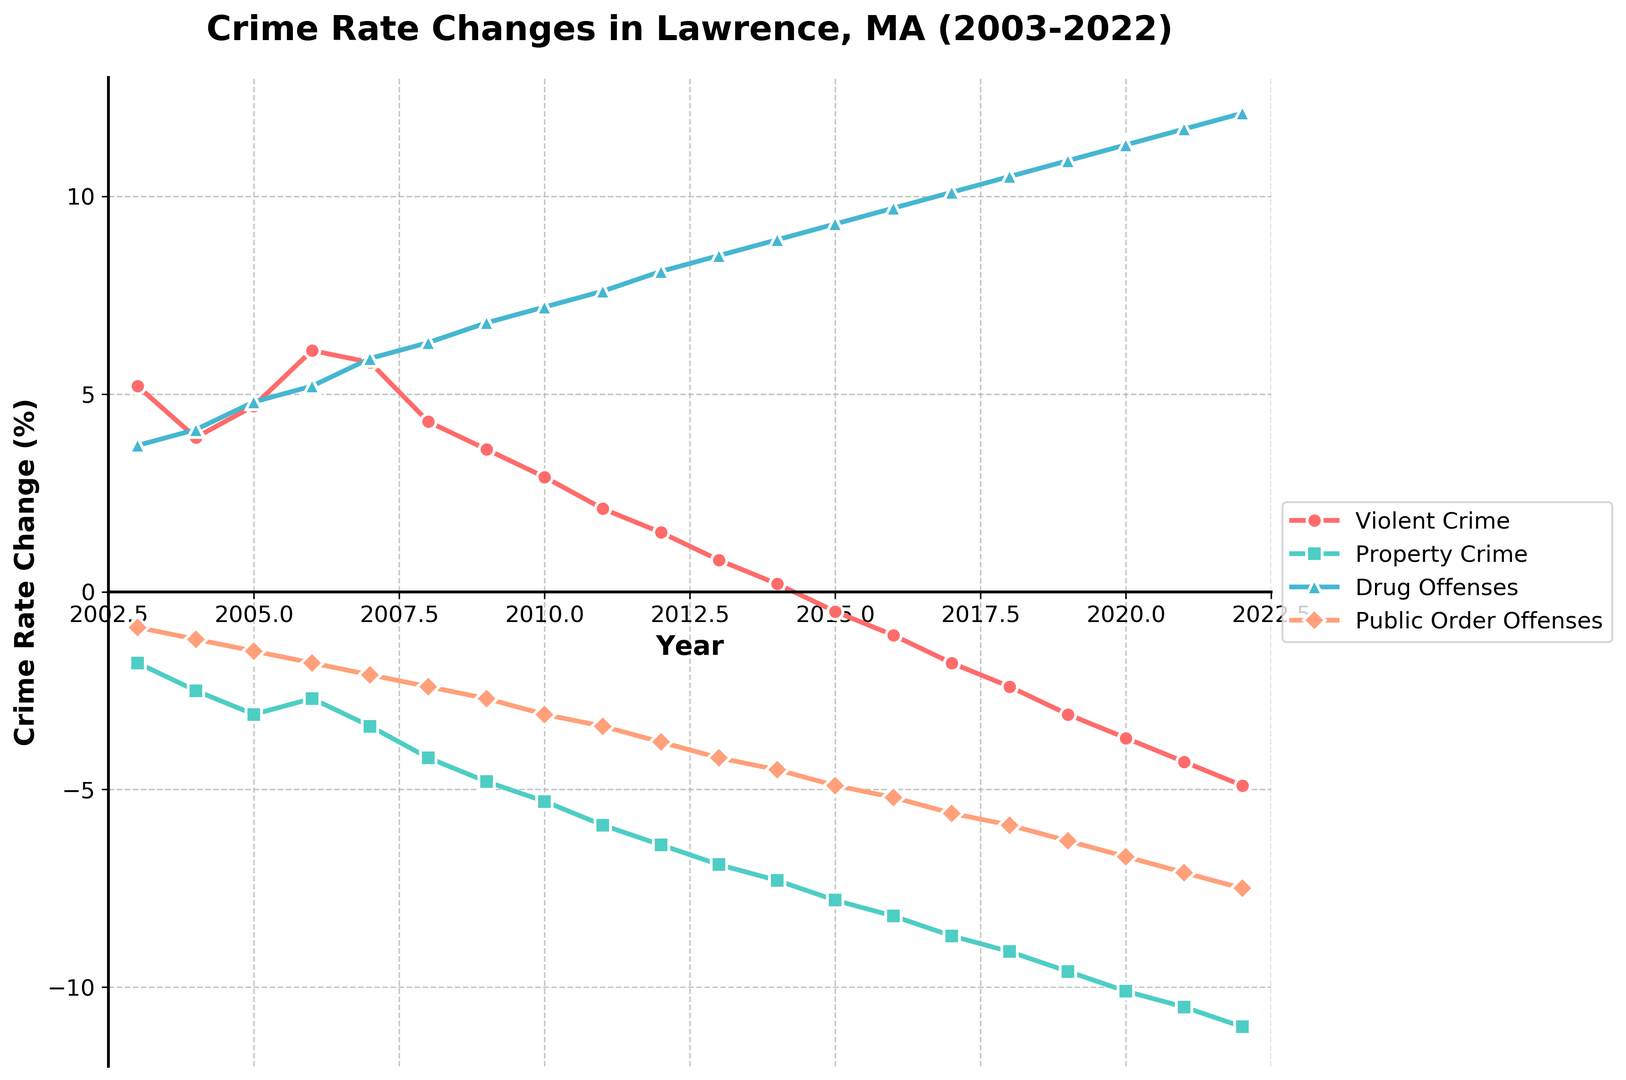When did Lawrence experience the highest rate of violent crimes? By observing the plot, the peak of the violent crime rate change occurs when the line representing violent crime reaches its highest point. This was in 2006, where the rate change is approximately 6.1%.
Answer: 2006 Which year saw the most significant decrease in property crime rates? The most significant decrease in property crime rates is shown by the lowest point on the property crime line. From the plot, this occurs in 2022 with a decrease of -11.0%.
Answer: 2022 How does the trend of public order offenses compare to violent crime over the 20-year period? Violent crime rates decrease from 5.2% in 2003 to -4.9% in 2022. Public Order Offenses follow a similar decline, decreasing from -0.9% in 2003 to -7.5% in 2022. Both show a general downward trend throughout the period.
Answer: Both show a general downward trend Identify the year where drug offenses had the largest increase. What was the crime rate change percentage? The largest increase in drug offenses can be found by identifying the highest point on the drug offenses line. This occurs in 2022 with a rate change of 12.1%.
Answer: 2022, 12.1% What were the changes in violent crime and drug offenses between 2010 and 2015? In 2010, the violent crime rate was 2.9%, and in 2015, it was -0.5%—a change of -3.4%. For drug offenses, the rate was 7.2% in 2010 and 9.3% in 2015—a change of 2.1%.
Answer: Violent crime: -3.4%, Drug offenses: 2.1% Which crime type shows the most consistent trend over the years, and in which direction? Property crimes show a consistent decreasing trend every year, going from -1.8% in 2003 to -11.0% in 2022. The line for property crimes consistently trends downward.
Answer: Property crimes, consistent decrease Based on the chart, which crime type had the greatest fluctuation in its rate changes? The crime type with the most fluctuations can be identified by examining the steepest rises and falls in its line. Violent Crimes show more fluctuation compared to other types, peaking at 6.1% in 2006 and declining to -4.9% in 2022.
Answer: Violent Crimes Was there any year where all crime types saw a decrease? If yes, which year? Observing all lines, there is no single year where all crime types saw a decrease. Each year, some types increased while others decreased.
Answer: No Which offense type shows an overall increase when considering the entire period from 2003 to 2022? The only offense type on the plot that shows an overall increase over the period is Drug Offenses, which went from 3.7% in 2003 to 12.1% in 2022.
Answer: Drug Offenses 